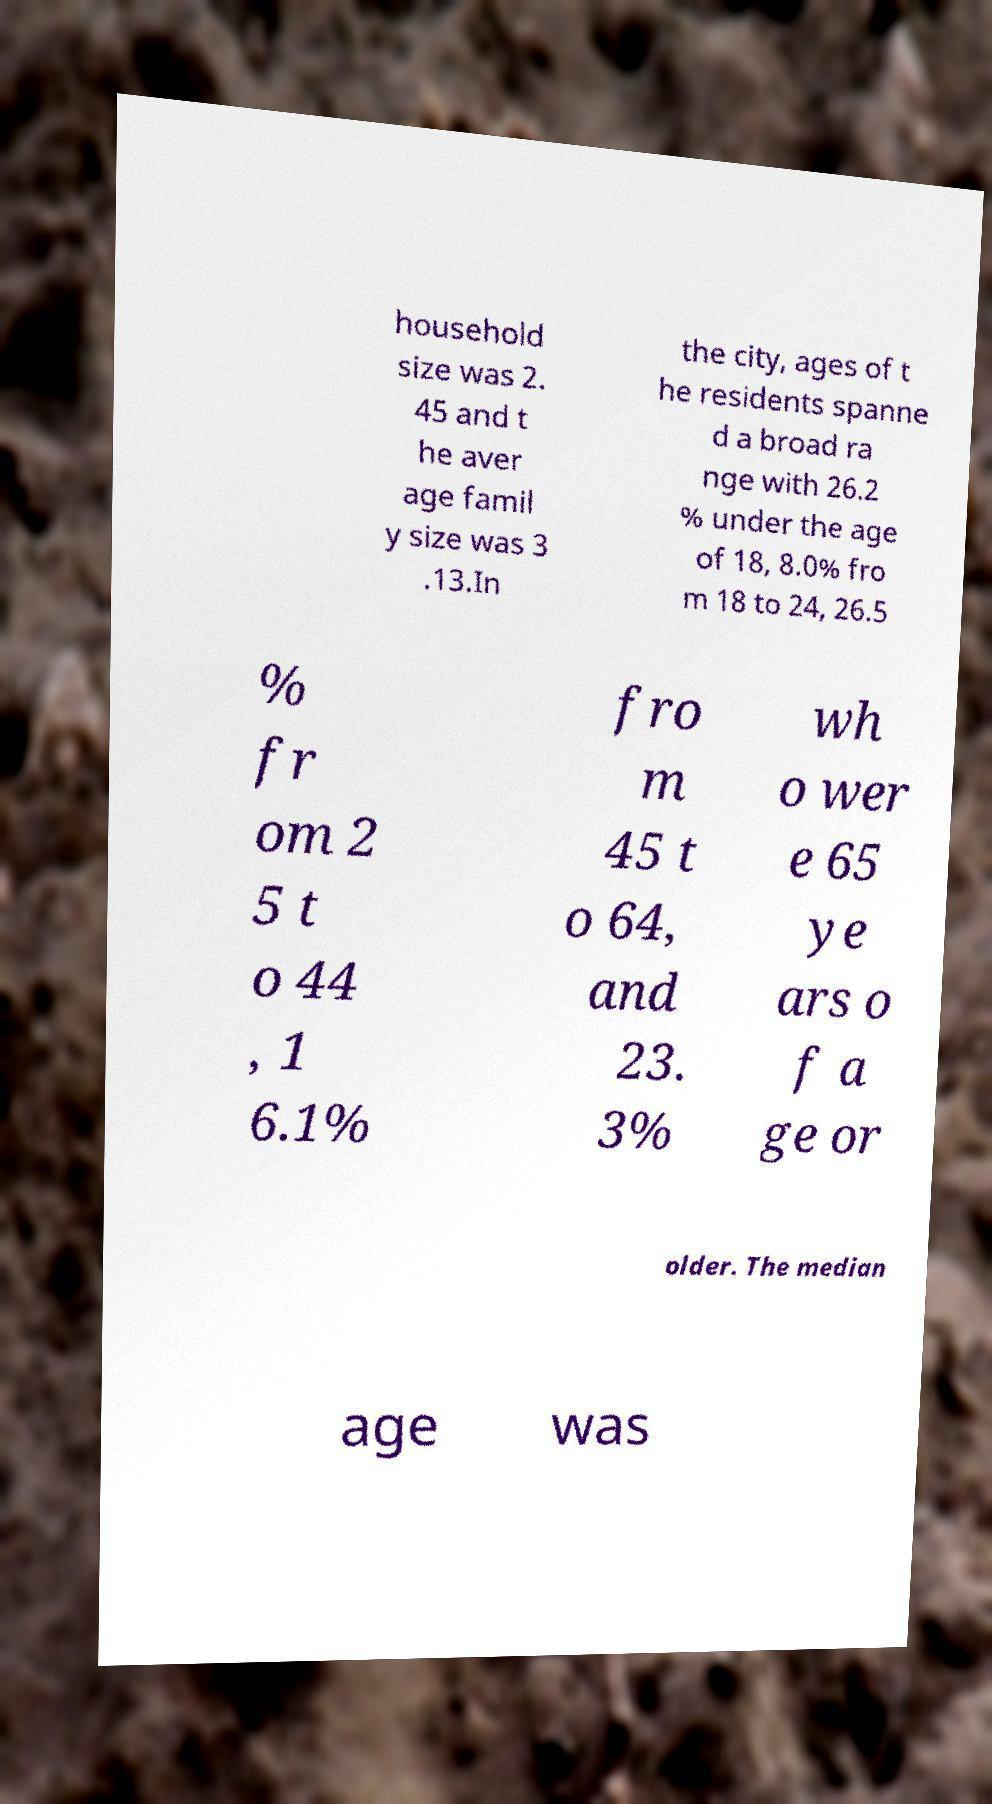Can you read and provide the text displayed in the image?This photo seems to have some interesting text. Can you extract and type it out for me? household size was 2. 45 and t he aver age famil y size was 3 .13.In the city, ages of t he residents spanne d a broad ra nge with 26.2 % under the age of 18, 8.0% fro m 18 to 24, 26.5 % fr om 2 5 t o 44 , 1 6.1% fro m 45 t o 64, and 23. 3% wh o wer e 65 ye ars o f a ge or older. The median age was 